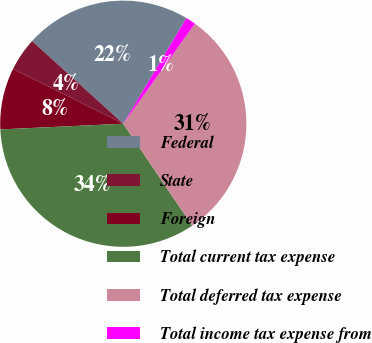Convert chart. <chart><loc_0><loc_0><loc_500><loc_500><pie_chart><fcel>Federal<fcel>State<fcel>Foreign<fcel>Total current tax expense<fcel>Total deferred tax expense<fcel>Total income tax expense from<nl><fcel>21.85%<fcel>4.38%<fcel>8.08%<fcel>33.72%<fcel>30.65%<fcel>1.32%<nl></chart> 